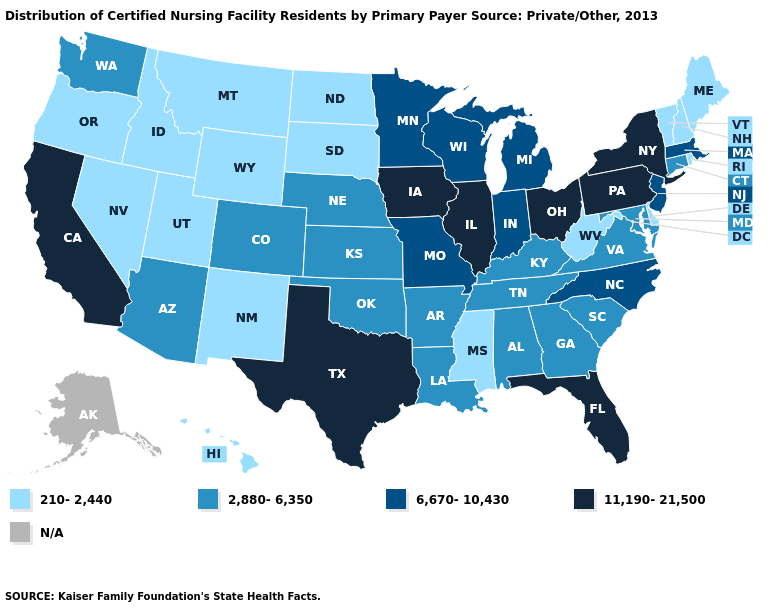Name the states that have a value in the range N/A?
Give a very brief answer. Alaska. Does the first symbol in the legend represent the smallest category?
Be succinct. Yes. What is the value of Alaska?
Concise answer only. N/A. Among the states that border Oklahoma , does New Mexico have the highest value?
Write a very short answer. No. Name the states that have a value in the range 6,670-10,430?
Keep it brief. Indiana, Massachusetts, Michigan, Minnesota, Missouri, New Jersey, North Carolina, Wisconsin. Name the states that have a value in the range 6,670-10,430?
Short answer required. Indiana, Massachusetts, Michigan, Minnesota, Missouri, New Jersey, North Carolina, Wisconsin. Does Missouri have the lowest value in the USA?
Write a very short answer. No. Name the states that have a value in the range 2,880-6,350?
Short answer required. Alabama, Arizona, Arkansas, Colorado, Connecticut, Georgia, Kansas, Kentucky, Louisiana, Maryland, Nebraska, Oklahoma, South Carolina, Tennessee, Virginia, Washington. What is the value of California?
Write a very short answer. 11,190-21,500. What is the lowest value in states that border Minnesota?
Write a very short answer. 210-2,440. What is the lowest value in the West?
Short answer required. 210-2,440. Does West Virginia have the lowest value in the USA?
Keep it brief. Yes. Does Wisconsin have the lowest value in the MidWest?
Short answer required. No. What is the highest value in states that border South Carolina?
Give a very brief answer. 6,670-10,430. 